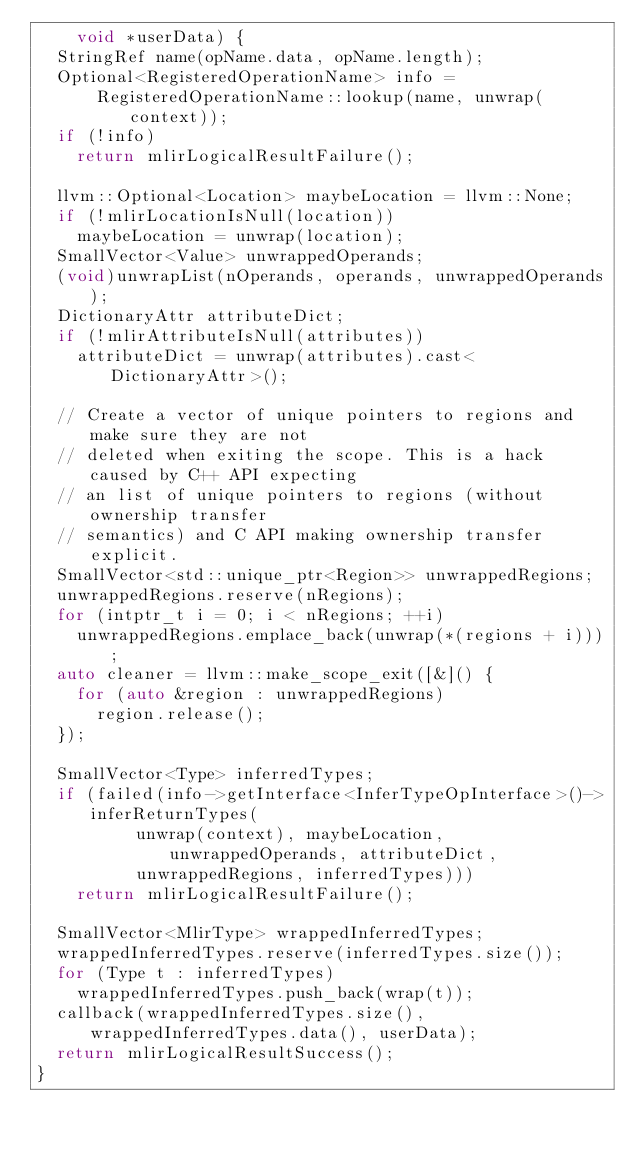<code> <loc_0><loc_0><loc_500><loc_500><_C++_>    void *userData) {
  StringRef name(opName.data, opName.length);
  Optional<RegisteredOperationName> info =
      RegisteredOperationName::lookup(name, unwrap(context));
  if (!info)
    return mlirLogicalResultFailure();

  llvm::Optional<Location> maybeLocation = llvm::None;
  if (!mlirLocationIsNull(location))
    maybeLocation = unwrap(location);
  SmallVector<Value> unwrappedOperands;
  (void)unwrapList(nOperands, operands, unwrappedOperands);
  DictionaryAttr attributeDict;
  if (!mlirAttributeIsNull(attributes))
    attributeDict = unwrap(attributes).cast<DictionaryAttr>();

  // Create a vector of unique pointers to regions and make sure they are not
  // deleted when exiting the scope. This is a hack caused by C++ API expecting
  // an list of unique pointers to regions (without ownership transfer
  // semantics) and C API making ownership transfer explicit.
  SmallVector<std::unique_ptr<Region>> unwrappedRegions;
  unwrappedRegions.reserve(nRegions);
  for (intptr_t i = 0; i < nRegions; ++i)
    unwrappedRegions.emplace_back(unwrap(*(regions + i)));
  auto cleaner = llvm::make_scope_exit([&]() {
    for (auto &region : unwrappedRegions)
      region.release();
  });

  SmallVector<Type> inferredTypes;
  if (failed(info->getInterface<InferTypeOpInterface>()->inferReturnTypes(
          unwrap(context), maybeLocation, unwrappedOperands, attributeDict,
          unwrappedRegions, inferredTypes)))
    return mlirLogicalResultFailure();

  SmallVector<MlirType> wrappedInferredTypes;
  wrappedInferredTypes.reserve(inferredTypes.size());
  for (Type t : inferredTypes)
    wrappedInferredTypes.push_back(wrap(t));
  callback(wrappedInferredTypes.size(), wrappedInferredTypes.data(), userData);
  return mlirLogicalResultSuccess();
}
</code> 